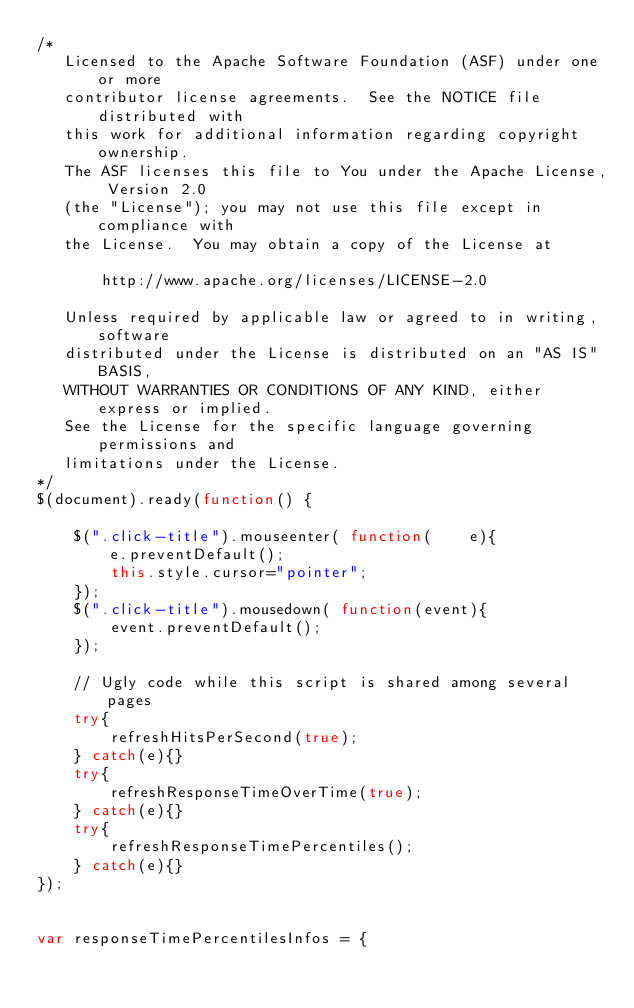<code> <loc_0><loc_0><loc_500><loc_500><_JavaScript_>/*
   Licensed to the Apache Software Foundation (ASF) under one or more
   contributor license agreements.  See the NOTICE file distributed with
   this work for additional information regarding copyright ownership.
   The ASF licenses this file to You under the Apache License, Version 2.0
   (the "License"); you may not use this file except in compliance with
   the License.  You may obtain a copy of the License at

       http://www.apache.org/licenses/LICENSE-2.0

   Unless required by applicable law or agreed to in writing, software
   distributed under the License is distributed on an "AS IS" BASIS,
   WITHOUT WARRANTIES OR CONDITIONS OF ANY KIND, either express or implied.
   See the License for the specific language governing permissions and
   limitations under the License.
*/
$(document).ready(function() {

    $(".click-title").mouseenter( function(    e){
        e.preventDefault();
        this.style.cursor="pointer";
    });
    $(".click-title").mousedown( function(event){
        event.preventDefault();
    });

    // Ugly code while this script is shared among several pages
    try{
        refreshHitsPerSecond(true);
    } catch(e){}
    try{
        refreshResponseTimeOverTime(true);
    } catch(e){}
    try{
        refreshResponseTimePercentiles();
    } catch(e){}
});


var responseTimePercentilesInfos = {</code> 